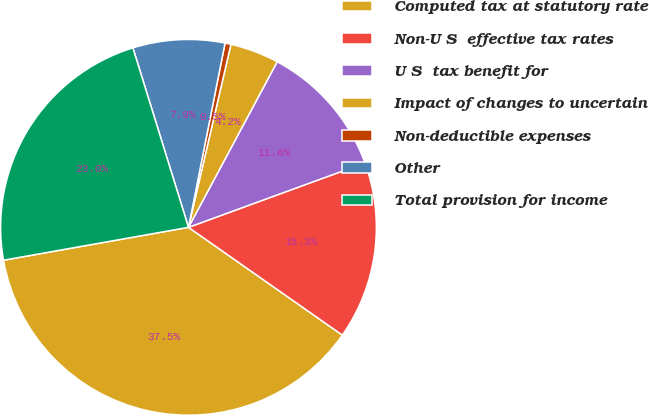Convert chart. <chart><loc_0><loc_0><loc_500><loc_500><pie_chart><fcel>Computed tax at statutory rate<fcel>Non-U�S� effective tax rates �<fcel>U�S� tax benefit for<fcel>Impact of changes to uncertain<fcel>Non-deductible expenses� � � �<fcel>Other � � � � � � � � � � � �<fcel>Total provision for income<nl><fcel>37.48%<fcel>15.3%<fcel>11.6%<fcel>4.2%<fcel>0.51%<fcel>7.9%<fcel>23.02%<nl></chart> 